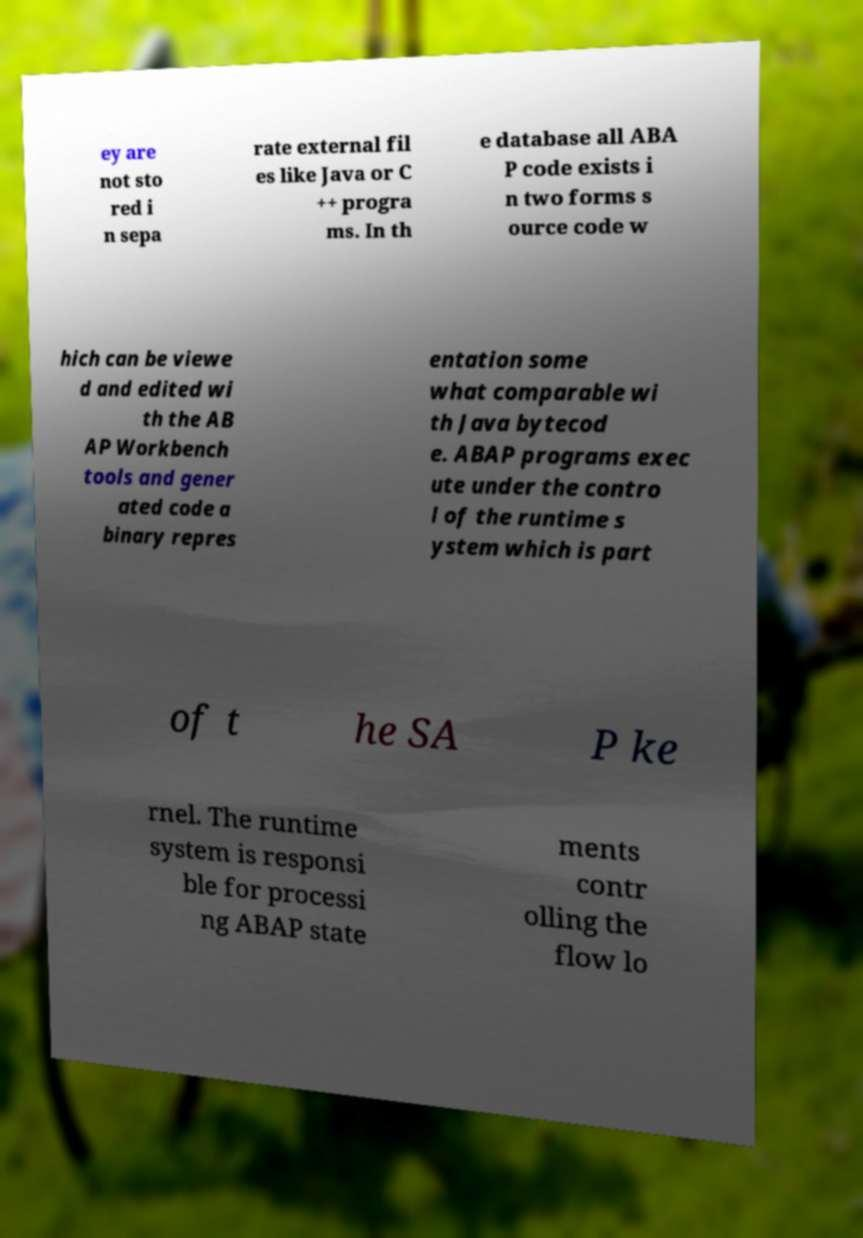Could you extract and type out the text from this image? ey are not sto red i n sepa rate external fil es like Java or C ++ progra ms. In th e database all ABA P code exists i n two forms s ource code w hich can be viewe d and edited wi th the AB AP Workbench tools and gener ated code a binary repres entation some what comparable wi th Java bytecod e. ABAP programs exec ute under the contro l of the runtime s ystem which is part of t he SA P ke rnel. The runtime system is responsi ble for processi ng ABAP state ments contr olling the flow lo 